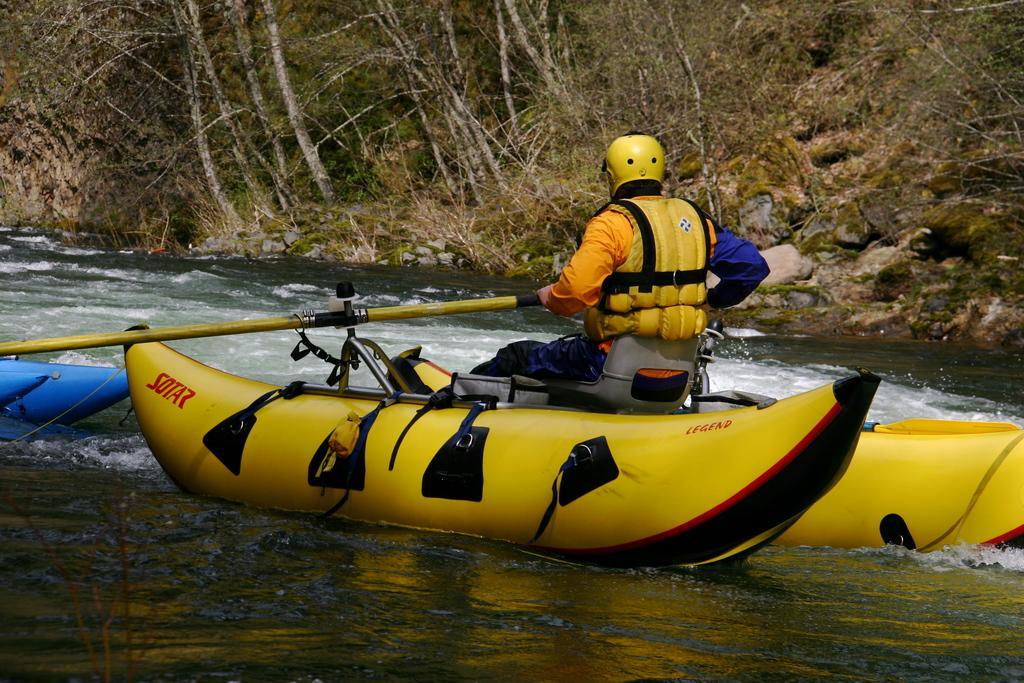In one or two sentences, can you explain what this image depicts? In this picture there is a person sitting and riding a boat and holding a paddle and wore a helmet. On the left side of the image we can see blue objects and water. In the background of the image we can see trees, grass and rocks. 